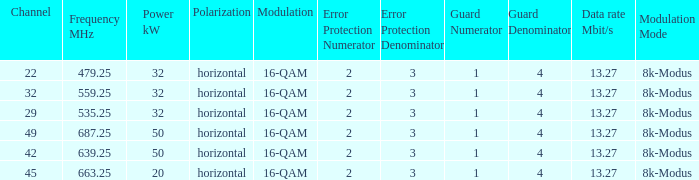Could you parse the entire table? {'header': ['Channel', 'Frequency MHz', 'Power kW', 'Polarization', 'Modulation', 'Error Protection Numerator', 'Error Protection Denominator', 'Guard Numerator', 'Guard Denominator', 'Data rate Mbit/s', 'Modulation Mode'], 'rows': [['22', '479.25', '32', 'horizontal', '16-QAM', '2', '3', '1', '4', '13.27', '8k-Modus'], ['32', '559.25', '32', 'horizontal', '16-QAM', '2', '3', '1', '4', '13.27', '8k-Modus'], ['29', '535.25', '32', 'horizontal', '16-QAM', '2', '3', '1', '4', '13.27', '8k-Modus'], ['49', '687.25', '50', 'horizontal', '16-QAM', '2', '3', '1', '4', '13.27', '8k-Modus'], ['42', '639.25', '50', 'horizontal', '16-QAM', '2', '3', '1', '4', '13.27', '8k-Modus'], ['45', '663.25', '20', 'horizontal', '16-QAM', '2', '3', '1', '4', '13.27', '8k-Modus']]} On channel 32, when the power is 32 kW horizontal, what is the frequency? 559,25 MHz. 